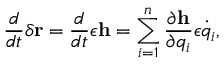<formula> <loc_0><loc_0><loc_500><loc_500>{ \frac { d } { d t } } \delta r = { \frac { d } { d t } } \epsilon h = \sum _ { i = 1 } ^ { n } { \frac { \partial h } { \partial q _ { i } } } \epsilon { \dot { q } } _ { i } ,</formula> 